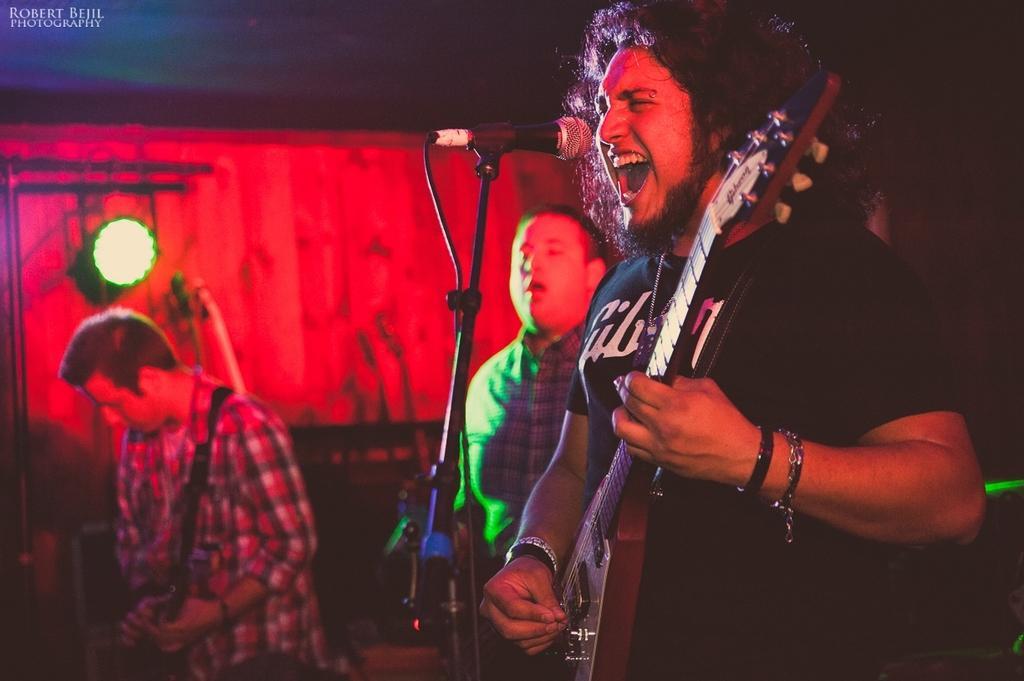Could you give a brief overview of what you see in this image? there are two persons playing guitar in front of one person there is a micro phone another person is playing some musical instrument. 